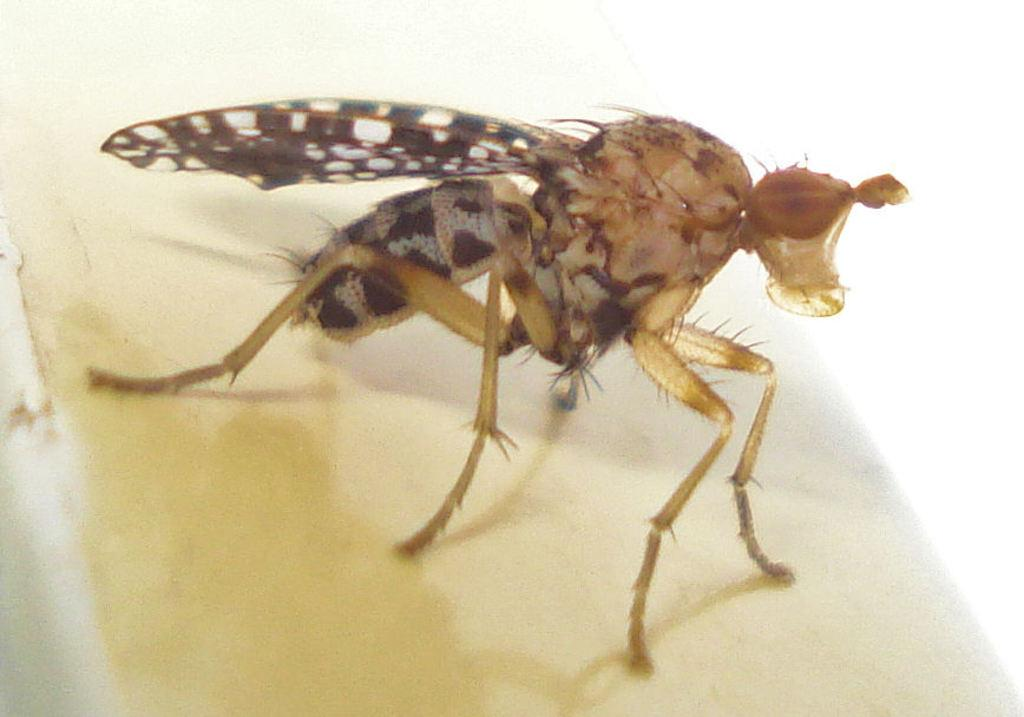What type of creature is present in the image? There is an insect in the image. What is the background or surface on which the insect is located? The insect is on a white surface. What family members can be seen interacting with the iron in the image? There is no family member or iron present in the image; it only features an insect on a white surface. What type of writing can be seen on the insect in the image? There is no writing present on the insect in the image. 